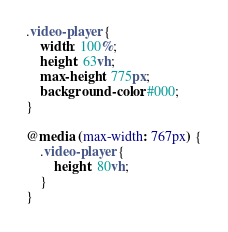<code> <loc_0><loc_0><loc_500><loc_500><_CSS_>.video-player {
    width: 100%;
    height: 63vh;
    max-height: 775px;
    background-color: #000;
}

@media (max-width: 767px) {
    .video-player {
        height: 80vh;
    }    
}
</code> 